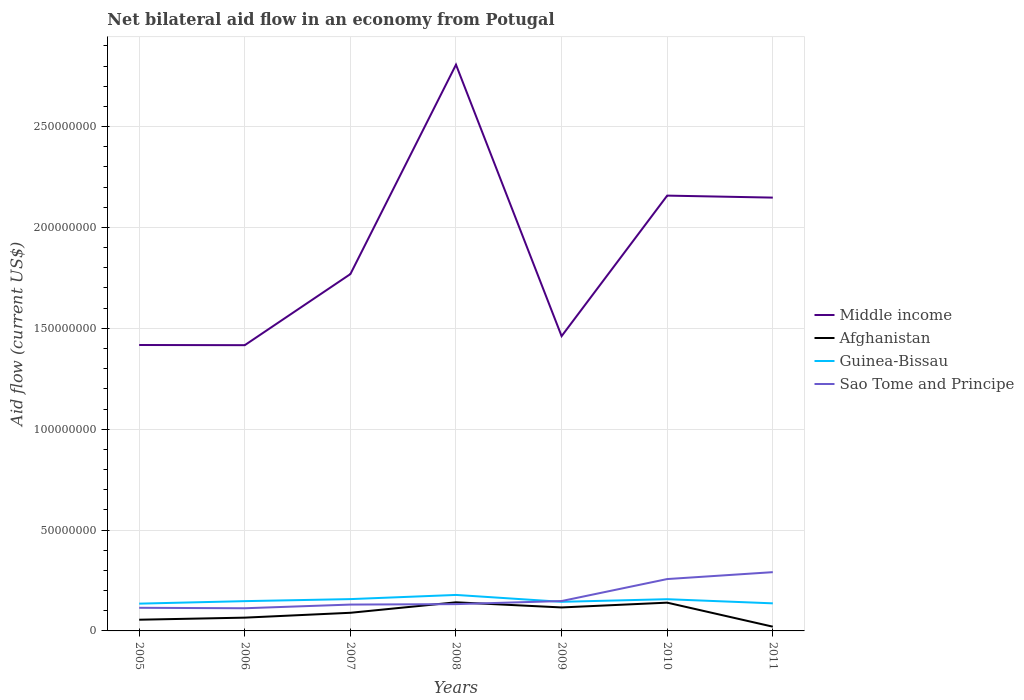Is the number of lines equal to the number of legend labels?
Provide a short and direct response. Yes. Across all years, what is the maximum net bilateral aid flow in Middle income?
Your answer should be compact. 1.42e+08. What is the total net bilateral aid flow in Afghanistan in the graph?
Offer a terse response. 6.89e+06. What is the difference between the highest and the second highest net bilateral aid flow in Sao Tome and Principe?
Give a very brief answer. 1.79e+07. What is the difference between the highest and the lowest net bilateral aid flow in Afghanistan?
Your answer should be compact. 3. Is the net bilateral aid flow in Afghanistan strictly greater than the net bilateral aid flow in Middle income over the years?
Offer a very short reply. Yes. What is the difference between two consecutive major ticks on the Y-axis?
Offer a very short reply. 5.00e+07. Are the values on the major ticks of Y-axis written in scientific E-notation?
Your answer should be very brief. No. How many legend labels are there?
Offer a very short reply. 4. How are the legend labels stacked?
Ensure brevity in your answer.  Vertical. What is the title of the graph?
Your answer should be compact. Net bilateral aid flow in an economy from Potugal. Does "Kosovo" appear as one of the legend labels in the graph?
Provide a succinct answer. No. What is the label or title of the Y-axis?
Make the answer very short. Aid flow (current US$). What is the Aid flow (current US$) in Middle income in 2005?
Offer a terse response. 1.42e+08. What is the Aid flow (current US$) in Afghanistan in 2005?
Keep it short and to the point. 5.55e+06. What is the Aid flow (current US$) of Guinea-Bissau in 2005?
Offer a terse response. 1.35e+07. What is the Aid flow (current US$) in Sao Tome and Principe in 2005?
Your answer should be compact. 1.15e+07. What is the Aid flow (current US$) in Middle income in 2006?
Offer a very short reply. 1.42e+08. What is the Aid flow (current US$) in Afghanistan in 2006?
Your response must be concise. 6.58e+06. What is the Aid flow (current US$) of Guinea-Bissau in 2006?
Provide a short and direct response. 1.48e+07. What is the Aid flow (current US$) in Sao Tome and Principe in 2006?
Make the answer very short. 1.12e+07. What is the Aid flow (current US$) of Middle income in 2007?
Provide a succinct answer. 1.77e+08. What is the Aid flow (current US$) in Afghanistan in 2007?
Ensure brevity in your answer.  8.99e+06. What is the Aid flow (current US$) in Guinea-Bissau in 2007?
Your answer should be compact. 1.58e+07. What is the Aid flow (current US$) of Sao Tome and Principe in 2007?
Give a very brief answer. 1.31e+07. What is the Aid flow (current US$) of Middle income in 2008?
Your answer should be compact. 2.81e+08. What is the Aid flow (current US$) of Afghanistan in 2008?
Provide a succinct answer. 1.42e+07. What is the Aid flow (current US$) in Guinea-Bissau in 2008?
Offer a terse response. 1.78e+07. What is the Aid flow (current US$) in Sao Tome and Principe in 2008?
Ensure brevity in your answer.  1.33e+07. What is the Aid flow (current US$) in Middle income in 2009?
Your answer should be very brief. 1.46e+08. What is the Aid flow (current US$) in Afghanistan in 2009?
Your answer should be compact. 1.16e+07. What is the Aid flow (current US$) in Guinea-Bissau in 2009?
Offer a terse response. 1.44e+07. What is the Aid flow (current US$) of Sao Tome and Principe in 2009?
Offer a terse response. 1.48e+07. What is the Aid flow (current US$) of Middle income in 2010?
Your response must be concise. 2.16e+08. What is the Aid flow (current US$) in Afghanistan in 2010?
Provide a short and direct response. 1.40e+07. What is the Aid flow (current US$) in Guinea-Bissau in 2010?
Offer a terse response. 1.57e+07. What is the Aid flow (current US$) of Sao Tome and Principe in 2010?
Keep it short and to the point. 2.57e+07. What is the Aid flow (current US$) of Middle income in 2011?
Keep it short and to the point. 2.15e+08. What is the Aid flow (current US$) in Afghanistan in 2011?
Give a very brief answer. 2.10e+06. What is the Aid flow (current US$) in Guinea-Bissau in 2011?
Your answer should be compact. 1.37e+07. What is the Aid flow (current US$) of Sao Tome and Principe in 2011?
Your response must be concise. 2.91e+07. Across all years, what is the maximum Aid flow (current US$) of Middle income?
Provide a short and direct response. 2.81e+08. Across all years, what is the maximum Aid flow (current US$) of Afghanistan?
Your response must be concise. 1.42e+07. Across all years, what is the maximum Aid flow (current US$) in Guinea-Bissau?
Keep it short and to the point. 1.78e+07. Across all years, what is the maximum Aid flow (current US$) of Sao Tome and Principe?
Your answer should be compact. 2.91e+07. Across all years, what is the minimum Aid flow (current US$) in Middle income?
Provide a succinct answer. 1.42e+08. Across all years, what is the minimum Aid flow (current US$) of Afghanistan?
Provide a short and direct response. 2.10e+06. Across all years, what is the minimum Aid flow (current US$) in Guinea-Bissau?
Offer a terse response. 1.35e+07. Across all years, what is the minimum Aid flow (current US$) of Sao Tome and Principe?
Provide a succinct answer. 1.12e+07. What is the total Aid flow (current US$) in Middle income in the graph?
Your answer should be very brief. 1.32e+09. What is the total Aid flow (current US$) in Afghanistan in the graph?
Your response must be concise. 6.30e+07. What is the total Aid flow (current US$) of Guinea-Bissau in the graph?
Ensure brevity in your answer.  1.06e+08. What is the total Aid flow (current US$) in Sao Tome and Principe in the graph?
Provide a succinct answer. 1.19e+08. What is the difference between the Aid flow (current US$) in Afghanistan in 2005 and that in 2006?
Offer a very short reply. -1.03e+06. What is the difference between the Aid flow (current US$) of Guinea-Bissau in 2005 and that in 2006?
Offer a terse response. -1.24e+06. What is the difference between the Aid flow (current US$) in Sao Tome and Principe in 2005 and that in 2006?
Your answer should be very brief. 2.20e+05. What is the difference between the Aid flow (current US$) of Middle income in 2005 and that in 2007?
Your response must be concise. -3.52e+07. What is the difference between the Aid flow (current US$) of Afghanistan in 2005 and that in 2007?
Provide a short and direct response. -3.44e+06. What is the difference between the Aid flow (current US$) in Guinea-Bissau in 2005 and that in 2007?
Provide a short and direct response. -2.25e+06. What is the difference between the Aid flow (current US$) in Sao Tome and Principe in 2005 and that in 2007?
Give a very brief answer. -1.60e+06. What is the difference between the Aid flow (current US$) of Middle income in 2005 and that in 2008?
Offer a very short reply. -1.39e+08. What is the difference between the Aid flow (current US$) in Afghanistan in 2005 and that in 2008?
Keep it short and to the point. -8.63e+06. What is the difference between the Aid flow (current US$) of Guinea-Bissau in 2005 and that in 2008?
Offer a very short reply. -4.32e+06. What is the difference between the Aid flow (current US$) of Sao Tome and Principe in 2005 and that in 2008?
Your response must be concise. -1.82e+06. What is the difference between the Aid flow (current US$) in Middle income in 2005 and that in 2009?
Your answer should be compact. -4.39e+06. What is the difference between the Aid flow (current US$) of Afghanistan in 2005 and that in 2009?
Provide a short and direct response. -6.09e+06. What is the difference between the Aid flow (current US$) in Guinea-Bissau in 2005 and that in 2009?
Give a very brief answer. -9.10e+05. What is the difference between the Aid flow (current US$) in Sao Tome and Principe in 2005 and that in 2009?
Make the answer very short. -3.35e+06. What is the difference between the Aid flow (current US$) in Middle income in 2005 and that in 2010?
Give a very brief answer. -7.40e+07. What is the difference between the Aid flow (current US$) in Afghanistan in 2005 and that in 2010?
Your answer should be very brief. -8.46e+06. What is the difference between the Aid flow (current US$) in Guinea-Bissau in 2005 and that in 2010?
Provide a succinct answer. -2.20e+06. What is the difference between the Aid flow (current US$) in Sao Tome and Principe in 2005 and that in 2010?
Your answer should be very brief. -1.42e+07. What is the difference between the Aid flow (current US$) in Middle income in 2005 and that in 2011?
Offer a very short reply. -7.31e+07. What is the difference between the Aid flow (current US$) in Afghanistan in 2005 and that in 2011?
Your answer should be very brief. 3.45e+06. What is the difference between the Aid flow (current US$) of Guinea-Bissau in 2005 and that in 2011?
Provide a short and direct response. -1.50e+05. What is the difference between the Aid flow (current US$) in Sao Tome and Principe in 2005 and that in 2011?
Ensure brevity in your answer.  -1.77e+07. What is the difference between the Aid flow (current US$) of Middle income in 2006 and that in 2007?
Your answer should be compact. -3.52e+07. What is the difference between the Aid flow (current US$) in Afghanistan in 2006 and that in 2007?
Provide a succinct answer. -2.41e+06. What is the difference between the Aid flow (current US$) in Guinea-Bissau in 2006 and that in 2007?
Provide a short and direct response. -1.01e+06. What is the difference between the Aid flow (current US$) in Sao Tome and Principe in 2006 and that in 2007?
Provide a short and direct response. -1.82e+06. What is the difference between the Aid flow (current US$) in Middle income in 2006 and that in 2008?
Ensure brevity in your answer.  -1.39e+08. What is the difference between the Aid flow (current US$) in Afghanistan in 2006 and that in 2008?
Provide a short and direct response. -7.60e+06. What is the difference between the Aid flow (current US$) in Guinea-Bissau in 2006 and that in 2008?
Ensure brevity in your answer.  -3.08e+06. What is the difference between the Aid flow (current US$) in Sao Tome and Principe in 2006 and that in 2008?
Your response must be concise. -2.04e+06. What is the difference between the Aid flow (current US$) of Middle income in 2006 and that in 2009?
Provide a succinct answer. -4.48e+06. What is the difference between the Aid flow (current US$) of Afghanistan in 2006 and that in 2009?
Provide a short and direct response. -5.06e+06. What is the difference between the Aid flow (current US$) of Guinea-Bissau in 2006 and that in 2009?
Offer a very short reply. 3.30e+05. What is the difference between the Aid flow (current US$) of Sao Tome and Principe in 2006 and that in 2009?
Your answer should be compact. -3.57e+06. What is the difference between the Aid flow (current US$) in Middle income in 2006 and that in 2010?
Offer a terse response. -7.41e+07. What is the difference between the Aid flow (current US$) in Afghanistan in 2006 and that in 2010?
Your answer should be very brief. -7.43e+06. What is the difference between the Aid flow (current US$) in Guinea-Bissau in 2006 and that in 2010?
Your answer should be very brief. -9.60e+05. What is the difference between the Aid flow (current US$) in Sao Tome and Principe in 2006 and that in 2010?
Give a very brief answer. -1.45e+07. What is the difference between the Aid flow (current US$) in Middle income in 2006 and that in 2011?
Your response must be concise. -7.32e+07. What is the difference between the Aid flow (current US$) of Afghanistan in 2006 and that in 2011?
Provide a succinct answer. 4.48e+06. What is the difference between the Aid flow (current US$) in Guinea-Bissau in 2006 and that in 2011?
Keep it short and to the point. 1.09e+06. What is the difference between the Aid flow (current US$) of Sao Tome and Principe in 2006 and that in 2011?
Your answer should be very brief. -1.79e+07. What is the difference between the Aid flow (current US$) of Middle income in 2007 and that in 2008?
Offer a very short reply. -1.04e+08. What is the difference between the Aid flow (current US$) in Afghanistan in 2007 and that in 2008?
Offer a very short reply. -5.19e+06. What is the difference between the Aid flow (current US$) in Guinea-Bissau in 2007 and that in 2008?
Give a very brief answer. -2.07e+06. What is the difference between the Aid flow (current US$) in Middle income in 2007 and that in 2009?
Keep it short and to the point. 3.08e+07. What is the difference between the Aid flow (current US$) of Afghanistan in 2007 and that in 2009?
Make the answer very short. -2.65e+06. What is the difference between the Aid flow (current US$) in Guinea-Bissau in 2007 and that in 2009?
Your answer should be compact. 1.34e+06. What is the difference between the Aid flow (current US$) in Sao Tome and Principe in 2007 and that in 2009?
Keep it short and to the point. -1.75e+06. What is the difference between the Aid flow (current US$) in Middle income in 2007 and that in 2010?
Offer a very short reply. -3.89e+07. What is the difference between the Aid flow (current US$) of Afghanistan in 2007 and that in 2010?
Give a very brief answer. -5.02e+06. What is the difference between the Aid flow (current US$) in Guinea-Bissau in 2007 and that in 2010?
Keep it short and to the point. 5.00e+04. What is the difference between the Aid flow (current US$) in Sao Tome and Principe in 2007 and that in 2010?
Offer a terse response. -1.26e+07. What is the difference between the Aid flow (current US$) of Middle income in 2007 and that in 2011?
Offer a very short reply. -3.79e+07. What is the difference between the Aid flow (current US$) of Afghanistan in 2007 and that in 2011?
Provide a succinct answer. 6.89e+06. What is the difference between the Aid flow (current US$) of Guinea-Bissau in 2007 and that in 2011?
Ensure brevity in your answer.  2.10e+06. What is the difference between the Aid flow (current US$) of Sao Tome and Principe in 2007 and that in 2011?
Ensure brevity in your answer.  -1.61e+07. What is the difference between the Aid flow (current US$) in Middle income in 2008 and that in 2009?
Your answer should be very brief. 1.35e+08. What is the difference between the Aid flow (current US$) in Afghanistan in 2008 and that in 2009?
Make the answer very short. 2.54e+06. What is the difference between the Aid flow (current US$) of Guinea-Bissau in 2008 and that in 2009?
Ensure brevity in your answer.  3.41e+06. What is the difference between the Aid flow (current US$) of Sao Tome and Principe in 2008 and that in 2009?
Provide a succinct answer. -1.53e+06. What is the difference between the Aid flow (current US$) of Middle income in 2008 and that in 2010?
Keep it short and to the point. 6.49e+07. What is the difference between the Aid flow (current US$) in Guinea-Bissau in 2008 and that in 2010?
Offer a very short reply. 2.12e+06. What is the difference between the Aid flow (current US$) of Sao Tome and Principe in 2008 and that in 2010?
Ensure brevity in your answer.  -1.24e+07. What is the difference between the Aid flow (current US$) of Middle income in 2008 and that in 2011?
Keep it short and to the point. 6.59e+07. What is the difference between the Aid flow (current US$) of Afghanistan in 2008 and that in 2011?
Provide a succinct answer. 1.21e+07. What is the difference between the Aid flow (current US$) of Guinea-Bissau in 2008 and that in 2011?
Keep it short and to the point. 4.17e+06. What is the difference between the Aid flow (current US$) of Sao Tome and Principe in 2008 and that in 2011?
Your answer should be very brief. -1.58e+07. What is the difference between the Aid flow (current US$) of Middle income in 2009 and that in 2010?
Keep it short and to the point. -6.97e+07. What is the difference between the Aid flow (current US$) in Afghanistan in 2009 and that in 2010?
Provide a short and direct response. -2.37e+06. What is the difference between the Aid flow (current US$) in Guinea-Bissau in 2009 and that in 2010?
Make the answer very short. -1.29e+06. What is the difference between the Aid flow (current US$) in Sao Tome and Principe in 2009 and that in 2010?
Provide a succinct answer. -1.09e+07. What is the difference between the Aid flow (current US$) in Middle income in 2009 and that in 2011?
Keep it short and to the point. -6.87e+07. What is the difference between the Aid flow (current US$) of Afghanistan in 2009 and that in 2011?
Make the answer very short. 9.54e+06. What is the difference between the Aid flow (current US$) in Guinea-Bissau in 2009 and that in 2011?
Offer a terse response. 7.60e+05. What is the difference between the Aid flow (current US$) in Sao Tome and Principe in 2009 and that in 2011?
Provide a short and direct response. -1.43e+07. What is the difference between the Aid flow (current US$) in Middle income in 2010 and that in 2011?
Ensure brevity in your answer.  9.90e+05. What is the difference between the Aid flow (current US$) in Afghanistan in 2010 and that in 2011?
Provide a succinct answer. 1.19e+07. What is the difference between the Aid flow (current US$) of Guinea-Bissau in 2010 and that in 2011?
Offer a terse response. 2.05e+06. What is the difference between the Aid flow (current US$) in Sao Tome and Principe in 2010 and that in 2011?
Provide a succinct answer. -3.42e+06. What is the difference between the Aid flow (current US$) of Middle income in 2005 and the Aid flow (current US$) of Afghanistan in 2006?
Give a very brief answer. 1.35e+08. What is the difference between the Aid flow (current US$) of Middle income in 2005 and the Aid flow (current US$) of Guinea-Bissau in 2006?
Your answer should be compact. 1.27e+08. What is the difference between the Aid flow (current US$) of Middle income in 2005 and the Aid flow (current US$) of Sao Tome and Principe in 2006?
Keep it short and to the point. 1.30e+08. What is the difference between the Aid flow (current US$) of Afghanistan in 2005 and the Aid flow (current US$) of Guinea-Bissau in 2006?
Your answer should be very brief. -9.21e+06. What is the difference between the Aid flow (current US$) in Afghanistan in 2005 and the Aid flow (current US$) in Sao Tome and Principe in 2006?
Your answer should be compact. -5.69e+06. What is the difference between the Aid flow (current US$) of Guinea-Bissau in 2005 and the Aid flow (current US$) of Sao Tome and Principe in 2006?
Your response must be concise. 2.28e+06. What is the difference between the Aid flow (current US$) in Middle income in 2005 and the Aid flow (current US$) in Afghanistan in 2007?
Provide a succinct answer. 1.33e+08. What is the difference between the Aid flow (current US$) of Middle income in 2005 and the Aid flow (current US$) of Guinea-Bissau in 2007?
Provide a succinct answer. 1.26e+08. What is the difference between the Aid flow (current US$) of Middle income in 2005 and the Aid flow (current US$) of Sao Tome and Principe in 2007?
Give a very brief answer. 1.29e+08. What is the difference between the Aid flow (current US$) of Afghanistan in 2005 and the Aid flow (current US$) of Guinea-Bissau in 2007?
Give a very brief answer. -1.02e+07. What is the difference between the Aid flow (current US$) in Afghanistan in 2005 and the Aid flow (current US$) in Sao Tome and Principe in 2007?
Your response must be concise. -7.51e+06. What is the difference between the Aid flow (current US$) in Guinea-Bissau in 2005 and the Aid flow (current US$) in Sao Tome and Principe in 2007?
Give a very brief answer. 4.60e+05. What is the difference between the Aid flow (current US$) of Middle income in 2005 and the Aid flow (current US$) of Afghanistan in 2008?
Your answer should be very brief. 1.28e+08. What is the difference between the Aid flow (current US$) in Middle income in 2005 and the Aid flow (current US$) in Guinea-Bissau in 2008?
Offer a terse response. 1.24e+08. What is the difference between the Aid flow (current US$) of Middle income in 2005 and the Aid flow (current US$) of Sao Tome and Principe in 2008?
Keep it short and to the point. 1.28e+08. What is the difference between the Aid flow (current US$) in Afghanistan in 2005 and the Aid flow (current US$) in Guinea-Bissau in 2008?
Offer a terse response. -1.23e+07. What is the difference between the Aid flow (current US$) in Afghanistan in 2005 and the Aid flow (current US$) in Sao Tome and Principe in 2008?
Your response must be concise. -7.73e+06. What is the difference between the Aid flow (current US$) in Middle income in 2005 and the Aid flow (current US$) in Afghanistan in 2009?
Give a very brief answer. 1.30e+08. What is the difference between the Aid flow (current US$) in Middle income in 2005 and the Aid flow (current US$) in Guinea-Bissau in 2009?
Offer a terse response. 1.27e+08. What is the difference between the Aid flow (current US$) in Middle income in 2005 and the Aid flow (current US$) in Sao Tome and Principe in 2009?
Keep it short and to the point. 1.27e+08. What is the difference between the Aid flow (current US$) in Afghanistan in 2005 and the Aid flow (current US$) in Guinea-Bissau in 2009?
Provide a short and direct response. -8.88e+06. What is the difference between the Aid flow (current US$) of Afghanistan in 2005 and the Aid flow (current US$) of Sao Tome and Principe in 2009?
Provide a succinct answer. -9.26e+06. What is the difference between the Aid flow (current US$) in Guinea-Bissau in 2005 and the Aid flow (current US$) in Sao Tome and Principe in 2009?
Provide a short and direct response. -1.29e+06. What is the difference between the Aid flow (current US$) in Middle income in 2005 and the Aid flow (current US$) in Afghanistan in 2010?
Provide a succinct answer. 1.28e+08. What is the difference between the Aid flow (current US$) of Middle income in 2005 and the Aid flow (current US$) of Guinea-Bissau in 2010?
Your response must be concise. 1.26e+08. What is the difference between the Aid flow (current US$) of Middle income in 2005 and the Aid flow (current US$) of Sao Tome and Principe in 2010?
Keep it short and to the point. 1.16e+08. What is the difference between the Aid flow (current US$) in Afghanistan in 2005 and the Aid flow (current US$) in Guinea-Bissau in 2010?
Provide a succinct answer. -1.02e+07. What is the difference between the Aid flow (current US$) of Afghanistan in 2005 and the Aid flow (current US$) of Sao Tome and Principe in 2010?
Make the answer very short. -2.02e+07. What is the difference between the Aid flow (current US$) in Guinea-Bissau in 2005 and the Aid flow (current US$) in Sao Tome and Principe in 2010?
Your response must be concise. -1.22e+07. What is the difference between the Aid flow (current US$) of Middle income in 2005 and the Aid flow (current US$) of Afghanistan in 2011?
Keep it short and to the point. 1.40e+08. What is the difference between the Aid flow (current US$) of Middle income in 2005 and the Aid flow (current US$) of Guinea-Bissau in 2011?
Your response must be concise. 1.28e+08. What is the difference between the Aid flow (current US$) of Middle income in 2005 and the Aid flow (current US$) of Sao Tome and Principe in 2011?
Your response must be concise. 1.13e+08. What is the difference between the Aid flow (current US$) of Afghanistan in 2005 and the Aid flow (current US$) of Guinea-Bissau in 2011?
Your response must be concise. -8.12e+06. What is the difference between the Aid flow (current US$) of Afghanistan in 2005 and the Aid flow (current US$) of Sao Tome and Principe in 2011?
Offer a very short reply. -2.36e+07. What is the difference between the Aid flow (current US$) in Guinea-Bissau in 2005 and the Aid flow (current US$) in Sao Tome and Principe in 2011?
Your answer should be compact. -1.56e+07. What is the difference between the Aid flow (current US$) of Middle income in 2006 and the Aid flow (current US$) of Afghanistan in 2007?
Provide a short and direct response. 1.33e+08. What is the difference between the Aid flow (current US$) of Middle income in 2006 and the Aid flow (current US$) of Guinea-Bissau in 2007?
Give a very brief answer. 1.26e+08. What is the difference between the Aid flow (current US$) of Middle income in 2006 and the Aid flow (current US$) of Sao Tome and Principe in 2007?
Your answer should be very brief. 1.29e+08. What is the difference between the Aid flow (current US$) of Afghanistan in 2006 and the Aid flow (current US$) of Guinea-Bissau in 2007?
Your answer should be compact. -9.19e+06. What is the difference between the Aid flow (current US$) of Afghanistan in 2006 and the Aid flow (current US$) of Sao Tome and Principe in 2007?
Ensure brevity in your answer.  -6.48e+06. What is the difference between the Aid flow (current US$) of Guinea-Bissau in 2006 and the Aid flow (current US$) of Sao Tome and Principe in 2007?
Provide a succinct answer. 1.70e+06. What is the difference between the Aid flow (current US$) of Middle income in 2006 and the Aid flow (current US$) of Afghanistan in 2008?
Provide a short and direct response. 1.27e+08. What is the difference between the Aid flow (current US$) of Middle income in 2006 and the Aid flow (current US$) of Guinea-Bissau in 2008?
Provide a succinct answer. 1.24e+08. What is the difference between the Aid flow (current US$) in Middle income in 2006 and the Aid flow (current US$) in Sao Tome and Principe in 2008?
Offer a terse response. 1.28e+08. What is the difference between the Aid flow (current US$) of Afghanistan in 2006 and the Aid flow (current US$) of Guinea-Bissau in 2008?
Ensure brevity in your answer.  -1.13e+07. What is the difference between the Aid flow (current US$) in Afghanistan in 2006 and the Aid flow (current US$) in Sao Tome and Principe in 2008?
Give a very brief answer. -6.70e+06. What is the difference between the Aid flow (current US$) of Guinea-Bissau in 2006 and the Aid flow (current US$) of Sao Tome and Principe in 2008?
Your answer should be very brief. 1.48e+06. What is the difference between the Aid flow (current US$) in Middle income in 2006 and the Aid flow (current US$) in Afghanistan in 2009?
Your answer should be compact. 1.30e+08. What is the difference between the Aid flow (current US$) in Middle income in 2006 and the Aid flow (current US$) in Guinea-Bissau in 2009?
Provide a short and direct response. 1.27e+08. What is the difference between the Aid flow (current US$) in Middle income in 2006 and the Aid flow (current US$) in Sao Tome and Principe in 2009?
Give a very brief answer. 1.27e+08. What is the difference between the Aid flow (current US$) of Afghanistan in 2006 and the Aid flow (current US$) of Guinea-Bissau in 2009?
Offer a very short reply. -7.85e+06. What is the difference between the Aid flow (current US$) of Afghanistan in 2006 and the Aid flow (current US$) of Sao Tome and Principe in 2009?
Ensure brevity in your answer.  -8.23e+06. What is the difference between the Aid flow (current US$) of Middle income in 2006 and the Aid flow (current US$) of Afghanistan in 2010?
Ensure brevity in your answer.  1.28e+08. What is the difference between the Aid flow (current US$) of Middle income in 2006 and the Aid flow (current US$) of Guinea-Bissau in 2010?
Provide a succinct answer. 1.26e+08. What is the difference between the Aid flow (current US$) in Middle income in 2006 and the Aid flow (current US$) in Sao Tome and Principe in 2010?
Provide a short and direct response. 1.16e+08. What is the difference between the Aid flow (current US$) of Afghanistan in 2006 and the Aid flow (current US$) of Guinea-Bissau in 2010?
Ensure brevity in your answer.  -9.14e+06. What is the difference between the Aid flow (current US$) of Afghanistan in 2006 and the Aid flow (current US$) of Sao Tome and Principe in 2010?
Provide a succinct answer. -1.91e+07. What is the difference between the Aid flow (current US$) of Guinea-Bissau in 2006 and the Aid flow (current US$) of Sao Tome and Principe in 2010?
Make the answer very short. -1.10e+07. What is the difference between the Aid flow (current US$) of Middle income in 2006 and the Aid flow (current US$) of Afghanistan in 2011?
Ensure brevity in your answer.  1.40e+08. What is the difference between the Aid flow (current US$) in Middle income in 2006 and the Aid flow (current US$) in Guinea-Bissau in 2011?
Provide a succinct answer. 1.28e+08. What is the difference between the Aid flow (current US$) of Middle income in 2006 and the Aid flow (current US$) of Sao Tome and Principe in 2011?
Offer a very short reply. 1.13e+08. What is the difference between the Aid flow (current US$) of Afghanistan in 2006 and the Aid flow (current US$) of Guinea-Bissau in 2011?
Provide a succinct answer. -7.09e+06. What is the difference between the Aid flow (current US$) in Afghanistan in 2006 and the Aid flow (current US$) in Sao Tome and Principe in 2011?
Ensure brevity in your answer.  -2.26e+07. What is the difference between the Aid flow (current US$) of Guinea-Bissau in 2006 and the Aid flow (current US$) of Sao Tome and Principe in 2011?
Your answer should be compact. -1.44e+07. What is the difference between the Aid flow (current US$) of Middle income in 2007 and the Aid flow (current US$) of Afghanistan in 2008?
Your answer should be compact. 1.63e+08. What is the difference between the Aid flow (current US$) in Middle income in 2007 and the Aid flow (current US$) in Guinea-Bissau in 2008?
Keep it short and to the point. 1.59e+08. What is the difference between the Aid flow (current US$) of Middle income in 2007 and the Aid flow (current US$) of Sao Tome and Principe in 2008?
Ensure brevity in your answer.  1.64e+08. What is the difference between the Aid flow (current US$) in Afghanistan in 2007 and the Aid flow (current US$) in Guinea-Bissau in 2008?
Provide a short and direct response. -8.85e+06. What is the difference between the Aid flow (current US$) of Afghanistan in 2007 and the Aid flow (current US$) of Sao Tome and Principe in 2008?
Keep it short and to the point. -4.29e+06. What is the difference between the Aid flow (current US$) in Guinea-Bissau in 2007 and the Aid flow (current US$) in Sao Tome and Principe in 2008?
Make the answer very short. 2.49e+06. What is the difference between the Aid flow (current US$) in Middle income in 2007 and the Aid flow (current US$) in Afghanistan in 2009?
Provide a succinct answer. 1.65e+08. What is the difference between the Aid flow (current US$) in Middle income in 2007 and the Aid flow (current US$) in Guinea-Bissau in 2009?
Make the answer very short. 1.62e+08. What is the difference between the Aid flow (current US$) in Middle income in 2007 and the Aid flow (current US$) in Sao Tome and Principe in 2009?
Provide a succinct answer. 1.62e+08. What is the difference between the Aid flow (current US$) of Afghanistan in 2007 and the Aid flow (current US$) of Guinea-Bissau in 2009?
Ensure brevity in your answer.  -5.44e+06. What is the difference between the Aid flow (current US$) of Afghanistan in 2007 and the Aid flow (current US$) of Sao Tome and Principe in 2009?
Provide a succinct answer. -5.82e+06. What is the difference between the Aid flow (current US$) of Guinea-Bissau in 2007 and the Aid flow (current US$) of Sao Tome and Principe in 2009?
Keep it short and to the point. 9.60e+05. What is the difference between the Aid flow (current US$) in Middle income in 2007 and the Aid flow (current US$) in Afghanistan in 2010?
Provide a succinct answer. 1.63e+08. What is the difference between the Aid flow (current US$) of Middle income in 2007 and the Aid flow (current US$) of Guinea-Bissau in 2010?
Your answer should be compact. 1.61e+08. What is the difference between the Aid flow (current US$) of Middle income in 2007 and the Aid flow (current US$) of Sao Tome and Principe in 2010?
Give a very brief answer. 1.51e+08. What is the difference between the Aid flow (current US$) of Afghanistan in 2007 and the Aid flow (current US$) of Guinea-Bissau in 2010?
Ensure brevity in your answer.  -6.73e+06. What is the difference between the Aid flow (current US$) in Afghanistan in 2007 and the Aid flow (current US$) in Sao Tome and Principe in 2010?
Make the answer very short. -1.67e+07. What is the difference between the Aid flow (current US$) of Guinea-Bissau in 2007 and the Aid flow (current US$) of Sao Tome and Principe in 2010?
Offer a terse response. -9.94e+06. What is the difference between the Aid flow (current US$) in Middle income in 2007 and the Aid flow (current US$) in Afghanistan in 2011?
Your response must be concise. 1.75e+08. What is the difference between the Aid flow (current US$) in Middle income in 2007 and the Aid flow (current US$) in Guinea-Bissau in 2011?
Ensure brevity in your answer.  1.63e+08. What is the difference between the Aid flow (current US$) of Middle income in 2007 and the Aid flow (current US$) of Sao Tome and Principe in 2011?
Ensure brevity in your answer.  1.48e+08. What is the difference between the Aid flow (current US$) of Afghanistan in 2007 and the Aid flow (current US$) of Guinea-Bissau in 2011?
Your answer should be very brief. -4.68e+06. What is the difference between the Aid flow (current US$) of Afghanistan in 2007 and the Aid flow (current US$) of Sao Tome and Principe in 2011?
Ensure brevity in your answer.  -2.01e+07. What is the difference between the Aid flow (current US$) in Guinea-Bissau in 2007 and the Aid flow (current US$) in Sao Tome and Principe in 2011?
Ensure brevity in your answer.  -1.34e+07. What is the difference between the Aid flow (current US$) of Middle income in 2008 and the Aid flow (current US$) of Afghanistan in 2009?
Make the answer very short. 2.69e+08. What is the difference between the Aid flow (current US$) in Middle income in 2008 and the Aid flow (current US$) in Guinea-Bissau in 2009?
Ensure brevity in your answer.  2.66e+08. What is the difference between the Aid flow (current US$) of Middle income in 2008 and the Aid flow (current US$) of Sao Tome and Principe in 2009?
Provide a short and direct response. 2.66e+08. What is the difference between the Aid flow (current US$) in Afghanistan in 2008 and the Aid flow (current US$) in Sao Tome and Principe in 2009?
Your answer should be compact. -6.30e+05. What is the difference between the Aid flow (current US$) in Guinea-Bissau in 2008 and the Aid flow (current US$) in Sao Tome and Principe in 2009?
Provide a short and direct response. 3.03e+06. What is the difference between the Aid flow (current US$) of Middle income in 2008 and the Aid flow (current US$) of Afghanistan in 2010?
Your response must be concise. 2.67e+08. What is the difference between the Aid flow (current US$) of Middle income in 2008 and the Aid flow (current US$) of Guinea-Bissau in 2010?
Make the answer very short. 2.65e+08. What is the difference between the Aid flow (current US$) in Middle income in 2008 and the Aid flow (current US$) in Sao Tome and Principe in 2010?
Offer a terse response. 2.55e+08. What is the difference between the Aid flow (current US$) in Afghanistan in 2008 and the Aid flow (current US$) in Guinea-Bissau in 2010?
Your answer should be very brief. -1.54e+06. What is the difference between the Aid flow (current US$) in Afghanistan in 2008 and the Aid flow (current US$) in Sao Tome and Principe in 2010?
Offer a terse response. -1.15e+07. What is the difference between the Aid flow (current US$) in Guinea-Bissau in 2008 and the Aid flow (current US$) in Sao Tome and Principe in 2010?
Your answer should be compact. -7.87e+06. What is the difference between the Aid flow (current US$) of Middle income in 2008 and the Aid flow (current US$) of Afghanistan in 2011?
Give a very brief answer. 2.79e+08. What is the difference between the Aid flow (current US$) of Middle income in 2008 and the Aid flow (current US$) of Guinea-Bissau in 2011?
Your answer should be very brief. 2.67e+08. What is the difference between the Aid flow (current US$) of Middle income in 2008 and the Aid flow (current US$) of Sao Tome and Principe in 2011?
Offer a very short reply. 2.52e+08. What is the difference between the Aid flow (current US$) in Afghanistan in 2008 and the Aid flow (current US$) in Guinea-Bissau in 2011?
Your response must be concise. 5.10e+05. What is the difference between the Aid flow (current US$) in Afghanistan in 2008 and the Aid flow (current US$) in Sao Tome and Principe in 2011?
Give a very brief answer. -1.50e+07. What is the difference between the Aid flow (current US$) of Guinea-Bissau in 2008 and the Aid flow (current US$) of Sao Tome and Principe in 2011?
Your response must be concise. -1.13e+07. What is the difference between the Aid flow (current US$) of Middle income in 2009 and the Aid flow (current US$) of Afghanistan in 2010?
Provide a short and direct response. 1.32e+08. What is the difference between the Aid flow (current US$) in Middle income in 2009 and the Aid flow (current US$) in Guinea-Bissau in 2010?
Your response must be concise. 1.30e+08. What is the difference between the Aid flow (current US$) in Middle income in 2009 and the Aid flow (current US$) in Sao Tome and Principe in 2010?
Your answer should be very brief. 1.20e+08. What is the difference between the Aid flow (current US$) of Afghanistan in 2009 and the Aid flow (current US$) of Guinea-Bissau in 2010?
Give a very brief answer. -4.08e+06. What is the difference between the Aid flow (current US$) in Afghanistan in 2009 and the Aid flow (current US$) in Sao Tome and Principe in 2010?
Provide a succinct answer. -1.41e+07. What is the difference between the Aid flow (current US$) in Guinea-Bissau in 2009 and the Aid flow (current US$) in Sao Tome and Principe in 2010?
Your answer should be very brief. -1.13e+07. What is the difference between the Aid flow (current US$) of Middle income in 2009 and the Aid flow (current US$) of Afghanistan in 2011?
Your response must be concise. 1.44e+08. What is the difference between the Aid flow (current US$) in Middle income in 2009 and the Aid flow (current US$) in Guinea-Bissau in 2011?
Offer a terse response. 1.32e+08. What is the difference between the Aid flow (current US$) of Middle income in 2009 and the Aid flow (current US$) of Sao Tome and Principe in 2011?
Ensure brevity in your answer.  1.17e+08. What is the difference between the Aid flow (current US$) in Afghanistan in 2009 and the Aid flow (current US$) in Guinea-Bissau in 2011?
Your answer should be compact. -2.03e+06. What is the difference between the Aid flow (current US$) of Afghanistan in 2009 and the Aid flow (current US$) of Sao Tome and Principe in 2011?
Ensure brevity in your answer.  -1.75e+07. What is the difference between the Aid flow (current US$) in Guinea-Bissau in 2009 and the Aid flow (current US$) in Sao Tome and Principe in 2011?
Provide a short and direct response. -1.47e+07. What is the difference between the Aid flow (current US$) of Middle income in 2010 and the Aid flow (current US$) of Afghanistan in 2011?
Ensure brevity in your answer.  2.14e+08. What is the difference between the Aid flow (current US$) in Middle income in 2010 and the Aid flow (current US$) in Guinea-Bissau in 2011?
Offer a terse response. 2.02e+08. What is the difference between the Aid flow (current US$) of Middle income in 2010 and the Aid flow (current US$) of Sao Tome and Principe in 2011?
Your response must be concise. 1.87e+08. What is the difference between the Aid flow (current US$) of Afghanistan in 2010 and the Aid flow (current US$) of Guinea-Bissau in 2011?
Ensure brevity in your answer.  3.40e+05. What is the difference between the Aid flow (current US$) in Afghanistan in 2010 and the Aid flow (current US$) in Sao Tome and Principe in 2011?
Offer a terse response. -1.51e+07. What is the difference between the Aid flow (current US$) in Guinea-Bissau in 2010 and the Aid flow (current US$) in Sao Tome and Principe in 2011?
Offer a very short reply. -1.34e+07. What is the average Aid flow (current US$) of Middle income per year?
Your response must be concise. 1.88e+08. What is the average Aid flow (current US$) in Afghanistan per year?
Keep it short and to the point. 9.01e+06. What is the average Aid flow (current US$) of Guinea-Bissau per year?
Give a very brief answer. 1.51e+07. What is the average Aid flow (current US$) in Sao Tome and Principe per year?
Your answer should be compact. 1.70e+07. In the year 2005, what is the difference between the Aid flow (current US$) of Middle income and Aid flow (current US$) of Afghanistan?
Keep it short and to the point. 1.36e+08. In the year 2005, what is the difference between the Aid flow (current US$) of Middle income and Aid flow (current US$) of Guinea-Bissau?
Provide a short and direct response. 1.28e+08. In the year 2005, what is the difference between the Aid flow (current US$) of Middle income and Aid flow (current US$) of Sao Tome and Principe?
Offer a terse response. 1.30e+08. In the year 2005, what is the difference between the Aid flow (current US$) of Afghanistan and Aid flow (current US$) of Guinea-Bissau?
Offer a terse response. -7.97e+06. In the year 2005, what is the difference between the Aid flow (current US$) of Afghanistan and Aid flow (current US$) of Sao Tome and Principe?
Keep it short and to the point. -5.91e+06. In the year 2005, what is the difference between the Aid flow (current US$) in Guinea-Bissau and Aid flow (current US$) in Sao Tome and Principe?
Make the answer very short. 2.06e+06. In the year 2006, what is the difference between the Aid flow (current US$) in Middle income and Aid flow (current US$) in Afghanistan?
Your answer should be compact. 1.35e+08. In the year 2006, what is the difference between the Aid flow (current US$) in Middle income and Aid flow (current US$) in Guinea-Bissau?
Your answer should be compact. 1.27e+08. In the year 2006, what is the difference between the Aid flow (current US$) of Middle income and Aid flow (current US$) of Sao Tome and Principe?
Your response must be concise. 1.30e+08. In the year 2006, what is the difference between the Aid flow (current US$) of Afghanistan and Aid flow (current US$) of Guinea-Bissau?
Keep it short and to the point. -8.18e+06. In the year 2006, what is the difference between the Aid flow (current US$) of Afghanistan and Aid flow (current US$) of Sao Tome and Principe?
Provide a succinct answer. -4.66e+06. In the year 2006, what is the difference between the Aid flow (current US$) in Guinea-Bissau and Aid flow (current US$) in Sao Tome and Principe?
Offer a terse response. 3.52e+06. In the year 2007, what is the difference between the Aid flow (current US$) in Middle income and Aid flow (current US$) in Afghanistan?
Keep it short and to the point. 1.68e+08. In the year 2007, what is the difference between the Aid flow (current US$) of Middle income and Aid flow (current US$) of Guinea-Bissau?
Ensure brevity in your answer.  1.61e+08. In the year 2007, what is the difference between the Aid flow (current US$) of Middle income and Aid flow (current US$) of Sao Tome and Principe?
Your answer should be compact. 1.64e+08. In the year 2007, what is the difference between the Aid flow (current US$) in Afghanistan and Aid flow (current US$) in Guinea-Bissau?
Keep it short and to the point. -6.78e+06. In the year 2007, what is the difference between the Aid flow (current US$) in Afghanistan and Aid flow (current US$) in Sao Tome and Principe?
Make the answer very short. -4.07e+06. In the year 2007, what is the difference between the Aid flow (current US$) of Guinea-Bissau and Aid flow (current US$) of Sao Tome and Principe?
Provide a short and direct response. 2.71e+06. In the year 2008, what is the difference between the Aid flow (current US$) in Middle income and Aid flow (current US$) in Afghanistan?
Your answer should be compact. 2.66e+08. In the year 2008, what is the difference between the Aid flow (current US$) in Middle income and Aid flow (current US$) in Guinea-Bissau?
Give a very brief answer. 2.63e+08. In the year 2008, what is the difference between the Aid flow (current US$) of Middle income and Aid flow (current US$) of Sao Tome and Principe?
Make the answer very short. 2.67e+08. In the year 2008, what is the difference between the Aid flow (current US$) in Afghanistan and Aid flow (current US$) in Guinea-Bissau?
Offer a very short reply. -3.66e+06. In the year 2008, what is the difference between the Aid flow (current US$) in Afghanistan and Aid flow (current US$) in Sao Tome and Principe?
Provide a short and direct response. 9.00e+05. In the year 2008, what is the difference between the Aid flow (current US$) of Guinea-Bissau and Aid flow (current US$) of Sao Tome and Principe?
Keep it short and to the point. 4.56e+06. In the year 2009, what is the difference between the Aid flow (current US$) in Middle income and Aid flow (current US$) in Afghanistan?
Your response must be concise. 1.34e+08. In the year 2009, what is the difference between the Aid flow (current US$) in Middle income and Aid flow (current US$) in Guinea-Bissau?
Your answer should be very brief. 1.32e+08. In the year 2009, what is the difference between the Aid flow (current US$) in Middle income and Aid flow (current US$) in Sao Tome and Principe?
Ensure brevity in your answer.  1.31e+08. In the year 2009, what is the difference between the Aid flow (current US$) of Afghanistan and Aid flow (current US$) of Guinea-Bissau?
Your answer should be compact. -2.79e+06. In the year 2009, what is the difference between the Aid flow (current US$) in Afghanistan and Aid flow (current US$) in Sao Tome and Principe?
Your response must be concise. -3.17e+06. In the year 2009, what is the difference between the Aid flow (current US$) in Guinea-Bissau and Aid flow (current US$) in Sao Tome and Principe?
Offer a terse response. -3.80e+05. In the year 2010, what is the difference between the Aid flow (current US$) of Middle income and Aid flow (current US$) of Afghanistan?
Your response must be concise. 2.02e+08. In the year 2010, what is the difference between the Aid flow (current US$) in Middle income and Aid flow (current US$) in Guinea-Bissau?
Your response must be concise. 2.00e+08. In the year 2010, what is the difference between the Aid flow (current US$) of Middle income and Aid flow (current US$) of Sao Tome and Principe?
Provide a short and direct response. 1.90e+08. In the year 2010, what is the difference between the Aid flow (current US$) in Afghanistan and Aid flow (current US$) in Guinea-Bissau?
Offer a terse response. -1.71e+06. In the year 2010, what is the difference between the Aid flow (current US$) of Afghanistan and Aid flow (current US$) of Sao Tome and Principe?
Ensure brevity in your answer.  -1.17e+07. In the year 2010, what is the difference between the Aid flow (current US$) in Guinea-Bissau and Aid flow (current US$) in Sao Tome and Principe?
Ensure brevity in your answer.  -9.99e+06. In the year 2011, what is the difference between the Aid flow (current US$) in Middle income and Aid flow (current US$) in Afghanistan?
Your answer should be compact. 2.13e+08. In the year 2011, what is the difference between the Aid flow (current US$) in Middle income and Aid flow (current US$) in Guinea-Bissau?
Ensure brevity in your answer.  2.01e+08. In the year 2011, what is the difference between the Aid flow (current US$) in Middle income and Aid flow (current US$) in Sao Tome and Principe?
Make the answer very short. 1.86e+08. In the year 2011, what is the difference between the Aid flow (current US$) in Afghanistan and Aid flow (current US$) in Guinea-Bissau?
Your answer should be very brief. -1.16e+07. In the year 2011, what is the difference between the Aid flow (current US$) in Afghanistan and Aid flow (current US$) in Sao Tome and Principe?
Offer a terse response. -2.70e+07. In the year 2011, what is the difference between the Aid flow (current US$) in Guinea-Bissau and Aid flow (current US$) in Sao Tome and Principe?
Keep it short and to the point. -1.55e+07. What is the ratio of the Aid flow (current US$) of Afghanistan in 2005 to that in 2006?
Offer a very short reply. 0.84. What is the ratio of the Aid flow (current US$) of Guinea-Bissau in 2005 to that in 2006?
Offer a very short reply. 0.92. What is the ratio of the Aid flow (current US$) in Sao Tome and Principe in 2005 to that in 2006?
Give a very brief answer. 1.02. What is the ratio of the Aid flow (current US$) of Middle income in 2005 to that in 2007?
Your answer should be very brief. 0.8. What is the ratio of the Aid flow (current US$) in Afghanistan in 2005 to that in 2007?
Offer a terse response. 0.62. What is the ratio of the Aid flow (current US$) in Guinea-Bissau in 2005 to that in 2007?
Give a very brief answer. 0.86. What is the ratio of the Aid flow (current US$) in Sao Tome and Principe in 2005 to that in 2007?
Provide a succinct answer. 0.88. What is the ratio of the Aid flow (current US$) in Middle income in 2005 to that in 2008?
Offer a terse response. 0.51. What is the ratio of the Aid flow (current US$) of Afghanistan in 2005 to that in 2008?
Give a very brief answer. 0.39. What is the ratio of the Aid flow (current US$) in Guinea-Bissau in 2005 to that in 2008?
Make the answer very short. 0.76. What is the ratio of the Aid flow (current US$) of Sao Tome and Principe in 2005 to that in 2008?
Your answer should be compact. 0.86. What is the ratio of the Aid flow (current US$) of Middle income in 2005 to that in 2009?
Your answer should be compact. 0.97. What is the ratio of the Aid flow (current US$) of Afghanistan in 2005 to that in 2009?
Make the answer very short. 0.48. What is the ratio of the Aid flow (current US$) in Guinea-Bissau in 2005 to that in 2009?
Your answer should be compact. 0.94. What is the ratio of the Aid flow (current US$) of Sao Tome and Principe in 2005 to that in 2009?
Provide a succinct answer. 0.77. What is the ratio of the Aid flow (current US$) of Middle income in 2005 to that in 2010?
Your answer should be compact. 0.66. What is the ratio of the Aid flow (current US$) in Afghanistan in 2005 to that in 2010?
Your answer should be compact. 0.4. What is the ratio of the Aid flow (current US$) in Guinea-Bissau in 2005 to that in 2010?
Offer a very short reply. 0.86. What is the ratio of the Aid flow (current US$) of Sao Tome and Principe in 2005 to that in 2010?
Ensure brevity in your answer.  0.45. What is the ratio of the Aid flow (current US$) in Middle income in 2005 to that in 2011?
Provide a short and direct response. 0.66. What is the ratio of the Aid flow (current US$) of Afghanistan in 2005 to that in 2011?
Provide a succinct answer. 2.64. What is the ratio of the Aid flow (current US$) of Guinea-Bissau in 2005 to that in 2011?
Provide a short and direct response. 0.99. What is the ratio of the Aid flow (current US$) of Sao Tome and Principe in 2005 to that in 2011?
Your response must be concise. 0.39. What is the ratio of the Aid flow (current US$) of Middle income in 2006 to that in 2007?
Ensure brevity in your answer.  0.8. What is the ratio of the Aid flow (current US$) in Afghanistan in 2006 to that in 2007?
Your response must be concise. 0.73. What is the ratio of the Aid flow (current US$) in Guinea-Bissau in 2006 to that in 2007?
Make the answer very short. 0.94. What is the ratio of the Aid flow (current US$) of Sao Tome and Principe in 2006 to that in 2007?
Your response must be concise. 0.86. What is the ratio of the Aid flow (current US$) in Middle income in 2006 to that in 2008?
Your response must be concise. 0.5. What is the ratio of the Aid flow (current US$) in Afghanistan in 2006 to that in 2008?
Offer a terse response. 0.46. What is the ratio of the Aid flow (current US$) of Guinea-Bissau in 2006 to that in 2008?
Your answer should be compact. 0.83. What is the ratio of the Aid flow (current US$) in Sao Tome and Principe in 2006 to that in 2008?
Give a very brief answer. 0.85. What is the ratio of the Aid flow (current US$) of Middle income in 2006 to that in 2009?
Your response must be concise. 0.97. What is the ratio of the Aid flow (current US$) of Afghanistan in 2006 to that in 2009?
Your answer should be very brief. 0.57. What is the ratio of the Aid flow (current US$) in Guinea-Bissau in 2006 to that in 2009?
Your answer should be very brief. 1.02. What is the ratio of the Aid flow (current US$) in Sao Tome and Principe in 2006 to that in 2009?
Give a very brief answer. 0.76. What is the ratio of the Aid flow (current US$) in Middle income in 2006 to that in 2010?
Your answer should be compact. 0.66. What is the ratio of the Aid flow (current US$) of Afghanistan in 2006 to that in 2010?
Your answer should be compact. 0.47. What is the ratio of the Aid flow (current US$) of Guinea-Bissau in 2006 to that in 2010?
Your response must be concise. 0.94. What is the ratio of the Aid flow (current US$) in Sao Tome and Principe in 2006 to that in 2010?
Keep it short and to the point. 0.44. What is the ratio of the Aid flow (current US$) of Middle income in 2006 to that in 2011?
Your answer should be very brief. 0.66. What is the ratio of the Aid flow (current US$) of Afghanistan in 2006 to that in 2011?
Provide a succinct answer. 3.13. What is the ratio of the Aid flow (current US$) in Guinea-Bissau in 2006 to that in 2011?
Your response must be concise. 1.08. What is the ratio of the Aid flow (current US$) in Sao Tome and Principe in 2006 to that in 2011?
Provide a short and direct response. 0.39. What is the ratio of the Aid flow (current US$) of Middle income in 2007 to that in 2008?
Offer a very short reply. 0.63. What is the ratio of the Aid flow (current US$) of Afghanistan in 2007 to that in 2008?
Your answer should be very brief. 0.63. What is the ratio of the Aid flow (current US$) in Guinea-Bissau in 2007 to that in 2008?
Provide a short and direct response. 0.88. What is the ratio of the Aid flow (current US$) in Sao Tome and Principe in 2007 to that in 2008?
Provide a succinct answer. 0.98. What is the ratio of the Aid flow (current US$) of Middle income in 2007 to that in 2009?
Your answer should be very brief. 1.21. What is the ratio of the Aid flow (current US$) of Afghanistan in 2007 to that in 2009?
Your response must be concise. 0.77. What is the ratio of the Aid flow (current US$) in Guinea-Bissau in 2007 to that in 2009?
Your answer should be very brief. 1.09. What is the ratio of the Aid flow (current US$) of Sao Tome and Principe in 2007 to that in 2009?
Your response must be concise. 0.88. What is the ratio of the Aid flow (current US$) in Middle income in 2007 to that in 2010?
Provide a short and direct response. 0.82. What is the ratio of the Aid flow (current US$) of Afghanistan in 2007 to that in 2010?
Ensure brevity in your answer.  0.64. What is the ratio of the Aid flow (current US$) of Sao Tome and Principe in 2007 to that in 2010?
Keep it short and to the point. 0.51. What is the ratio of the Aid flow (current US$) of Middle income in 2007 to that in 2011?
Your response must be concise. 0.82. What is the ratio of the Aid flow (current US$) of Afghanistan in 2007 to that in 2011?
Provide a short and direct response. 4.28. What is the ratio of the Aid flow (current US$) in Guinea-Bissau in 2007 to that in 2011?
Make the answer very short. 1.15. What is the ratio of the Aid flow (current US$) of Sao Tome and Principe in 2007 to that in 2011?
Provide a short and direct response. 0.45. What is the ratio of the Aid flow (current US$) of Middle income in 2008 to that in 2009?
Offer a terse response. 1.92. What is the ratio of the Aid flow (current US$) of Afghanistan in 2008 to that in 2009?
Provide a short and direct response. 1.22. What is the ratio of the Aid flow (current US$) in Guinea-Bissau in 2008 to that in 2009?
Give a very brief answer. 1.24. What is the ratio of the Aid flow (current US$) of Sao Tome and Principe in 2008 to that in 2009?
Keep it short and to the point. 0.9. What is the ratio of the Aid flow (current US$) in Middle income in 2008 to that in 2010?
Make the answer very short. 1.3. What is the ratio of the Aid flow (current US$) in Afghanistan in 2008 to that in 2010?
Your answer should be very brief. 1.01. What is the ratio of the Aid flow (current US$) of Guinea-Bissau in 2008 to that in 2010?
Provide a short and direct response. 1.13. What is the ratio of the Aid flow (current US$) in Sao Tome and Principe in 2008 to that in 2010?
Your answer should be compact. 0.52. What is the ratio of the Aid flow (current US$) of Middle income in 2008 to that in 2011?
Keep it short and to the point. 1.31. What is the ratio of the Aid flow (current US$) of Afghanistan in 2008 to that in 2011?
Your answer should be very brief. 6.75. What is the ratio of the Aid flow (current US$) of Guinea-Bissau in 2008 to that in 2011?
Your answer should be very brief. 1.3. What is the ratio of the Aid flow (current US$) in Sao Tome and Principe in 2008 to that in 2011?
Offer a terse response. 0.46. What is the ratio of the Aid flow (current US$) in Middle income in 2009 to that in 2010?
Offer a very short reply. 0.68. What is the ratio of the Aid flow (current US$) of Afghanistan in 2009 to that in 2010?
Make the answer very short. 0.83. What is the ratio of the Aid flow (current US$) in Guinea-Bissau in 2009 to that in 2010?
Your answer should be compact. 0.92. What is the ratio of the Aid flow (current US$) of Sao Tome and Principe in 2009 to that in 2010?
Ensure brevity in your answer.  0.58. What is the ratio of the Aid flow (current US$) in Middle income in 2009 to that in 2011?
Keep it short and to the point. 0.68. What is the ratio of the Aid flow (current US$) of Afghanistan in 2009 to that in 2011?
Offer a terse response. 5.54. What is the ratio of the Aid flow (current US$) in Guinea-Bissau in 2009 to that in 2011?
Make the answer very short. 1.06. What is the ratio of the Aid flow (current US$) in Sao Tome and Principe in 2009 to that in 2011?
Your answer should be compact. 0.51. What is the ratio of the Aid flow (current US$) in Middle income in 2010 to that in 2011?
Make the answer very short. 1. What is the ratio of the Aid flow (current US$) in Afghanistan in 2010 to that in 2011?
Offer a terse response. 6.67. What is the ratio of the Aid flow (current US$) of Guinea-Bissau in 2010 to that in 2011?
Your response must be concise. 1.15. What is the ratio of the Aid flow (current US$) in Sao Tome and Principe in 2010 to that in 2011?
Your answer should be compact. 0.88. What is the difference between the highest and the second highest Aid flow (current US$) of Middle income?
Your answer should be very brief. 6.49e+07. What is the difference between the highest and the second highest Aid flow (current US$) in Guinea-Bissau?
Provide a short and direct response. 2.07e+06. What is the difference between the highest and the second highest Aid flow (current US$) of Sao Tome and Principe?
Ensure brevity in your answer.  3.42e+06. What is the difference between the highest and the lowest Aid flow (current US$) of Middle income?
Offer a terse response. 1.39e+08. What is the difference between the highest and the lowest Aid flow (current US$) in Afghanistan?
Your response must be concise. 1.21e+07. What is the difference between the highest and the lowest Aid flow (current US$) of Guinea-Bissau?
Your answer should be very brief. 4.32e+06. What is the difference between the highest and the lowest Aid flow (current US$) in Sao Tome and Principe?
Give a very brief answer. 1.79e+07. 